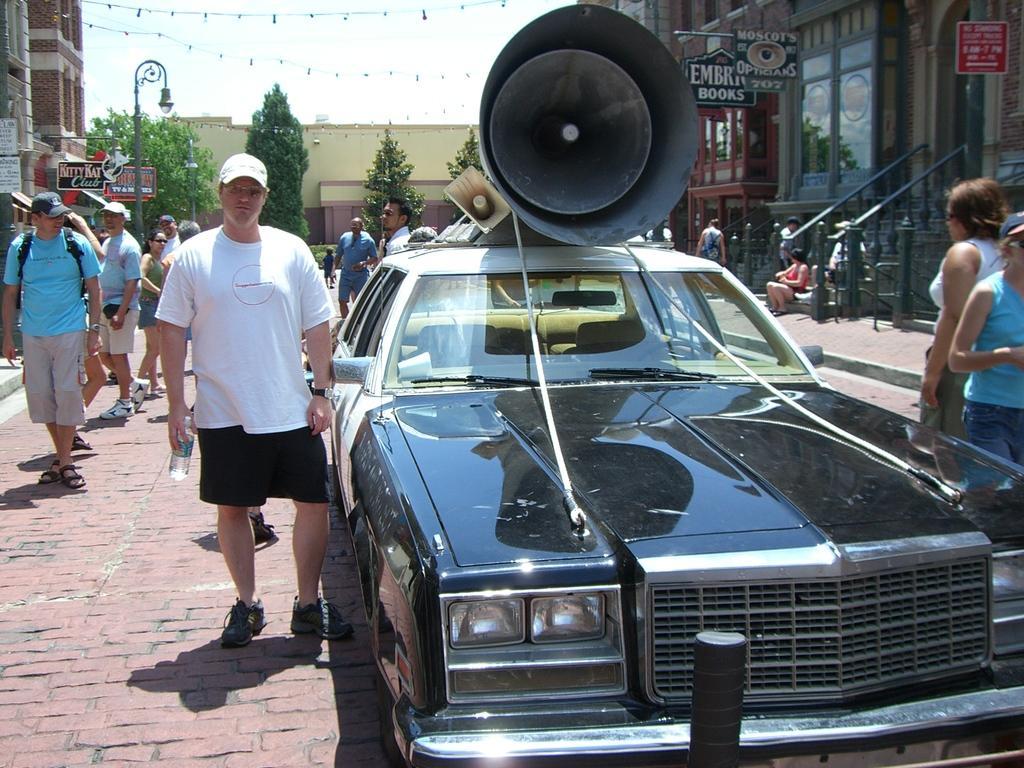How would you summarize this image in a sentence or two? There is a car. On the car there are megaphones. There are many people. Some are wearing caps. On the sides there are buildings with name boards, steps and railings. There is a light pole. In the background there are trees, building and sky. 